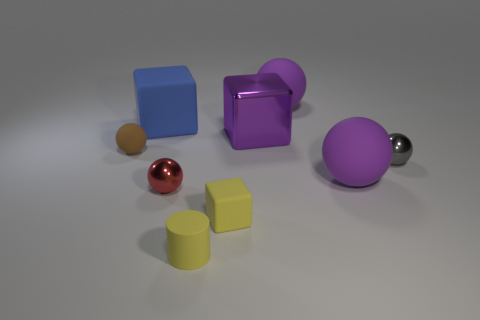Subtract all gray spheres. How many spheres are left? 4 Subtract all small matte spheres. How many spheres are left? 4 Subtract all blue spheres. Subtract all cyan cylinders. How many spheres are left? 5 Add 1 tiny gray things. How many objects exist? 10 Subtract all balls. How many objects are left? 4 Add 4 gray objects. How many gray objects exist? 5 Subtract 1 brown balls. How many objects are left? 8 Subtract all big shiny objects. Subtract all tiny yellow cylinders. How many objects are left? 7 Add 3 big purple metallic objects. How many big purple metallic objects are left? 4 